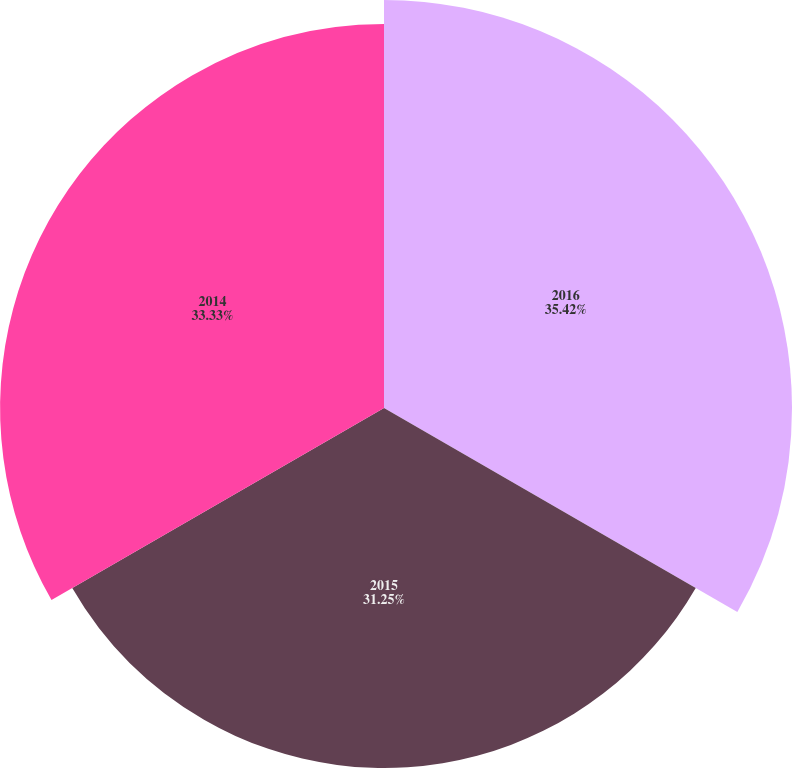Convert chart. <chart><loc_0><loc_0><loc_500><loc_500><pie_chart><fcel>2016<fcel>2015<fcel>2014<nl><fcel>35.42%<fcel>31.25%<fcel>33.33%<nl></chart> 